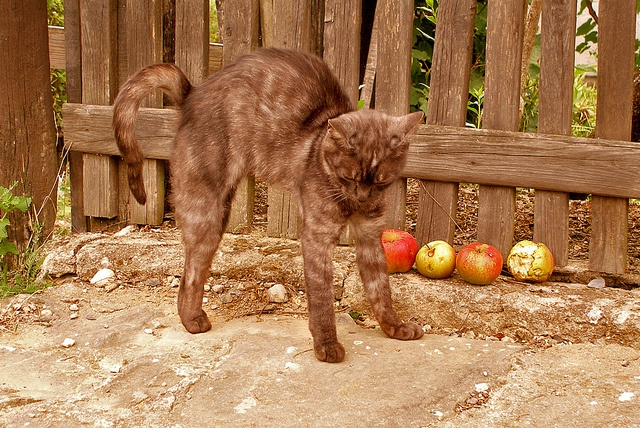Describe the objects in this image and their specific colors. I can see cat in maroon, brown, salmon, and tan tones, apple in maroon, red, brown, and orange tones, and apple in maroon, orange, khaki, and brown tones in this image. 